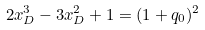<formula> <loc_0><loc_0><loc_500><loc_500>2 x _ { D } ^ { 3 } - 3 x _ { D } ^ { 2 } + 1 = ( 1 + q _ { 0 } ) ^ { 2 }</formula> 